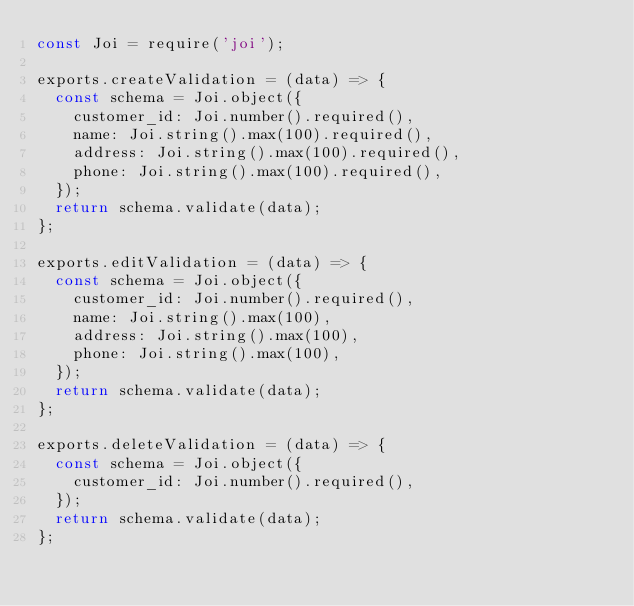Convert code to text. <code><loc_0><loc_0><loc_500><loc_500><_JavaScript_>const Joi = require('joi');

exports.createValidation = (data) => {
  const schema = Joi.object({
    customer_id: Joi.number().required(),
    name: Joi.string().max(100).required(),
    address: Joi.string().max(100).required(),
    phone: Joi.string().max(100).required(),
  });
  return schema.validate(data);
};

exports.editValidation = (data) => {
  const schema = Joi.object({
    customer_id: Joi.number().required(),
    name: Joi.string().max(100),
    address: Joi.string().max(100),
    phone: Joi.string().max(100),
  });
  return schema.validate(data);
};

exports.deleteValidation = (data) => {
  const schema = Joi.object({
    customer_id: Joi.number().required(),
  });
  return schema.validate(data);
};
</code> 